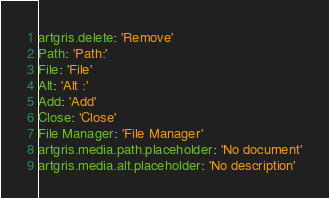Convert code to text. <code><loc_0><loc_0><loc_500><loc_500><_YAML_>artgris.delete: 'Remove'
Path: 'Path:'
File: 'File'
Alt: 'Alt :'
Add: 'Add'
Close: 'Close'
File Manager: 'File Manager'
artgris.media.path.placeholder: 'No document'
artgris.media.alt.placeholder: 'No description'
</code> 